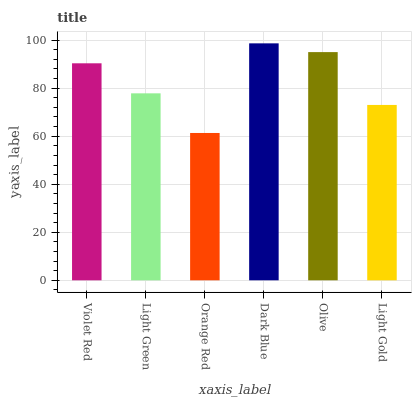Is Orange Red the minimum?
Answer yes or no. Yes. Is Dark Blue the maximum?
Answer yes or no. Yes. Is Light Green the minimum?
Answer yes or no. No. Is Light Green the maximum?
Answer yes or no. No. Is Violet Red greater than Light Green?
Answer yes or no. Yes. Is Light Green less than Violet Red?
Answer yes or no. Yes. Is Light Green greater than Violet Red?
Answer yes or no. No. Is Violet Red less than Light Green?
Answer yes or no. No. Is Violet Red the high median?
Answer yes or no. Yes. Is Light Green the low median?
Answer yes or no. Yes. Is Olive the high median?
Answer yes or no. No. Is Dark Blue the low median?
Answer yes or no. No. 